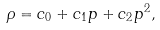<formula> <loc_0><loc_0><loc_500><loc_500>\rho = c _ { 0 } + c _ { 1 } p + c _ { 2 } p ^ { 2 } ,</formula> 